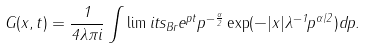<formula> <loc_0><loc_0><loc_500><loc_500>G ( x , t ) = \frac { 1 } { 4 \lambda \pi i } \int \lim i t s _ { B r } e ^ { p t } p ^ { - \frac { \alpha } { 2 } } \exp ( - | x | \lambda ^ { - 1 } p ^ { \alpha / 2 } ) d p .</formula> 